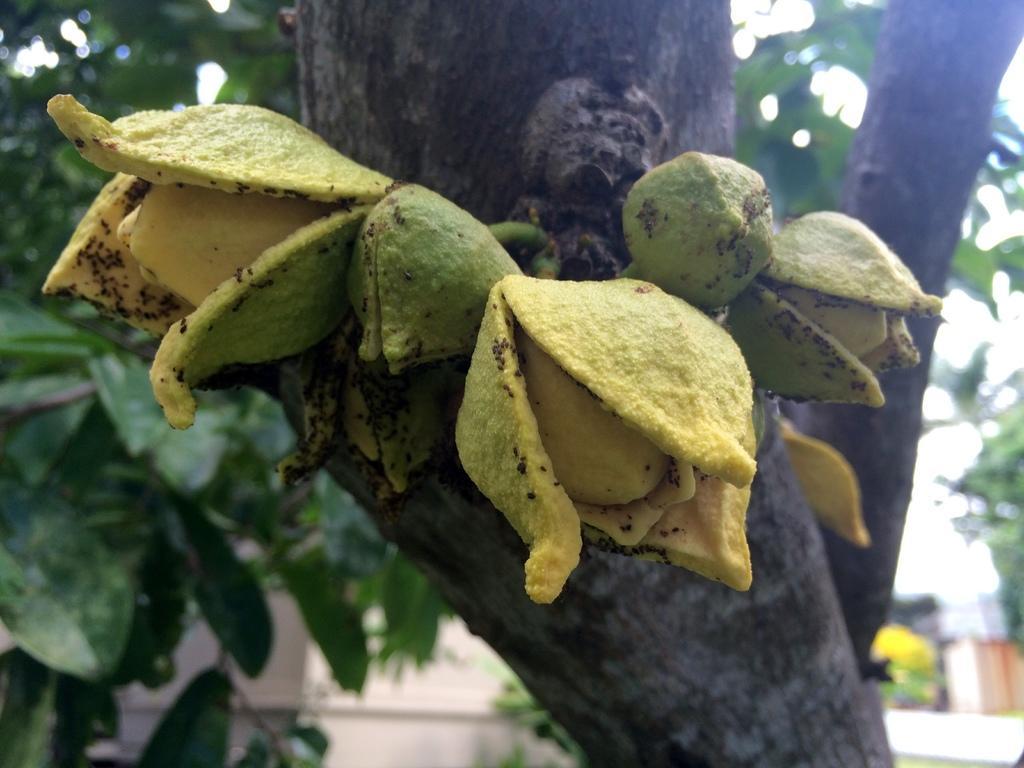Can you describe this image briefly? In this image I can see a there are some fruits to the trunk. The fruits are in yellow and green colors. The background is blurred. 